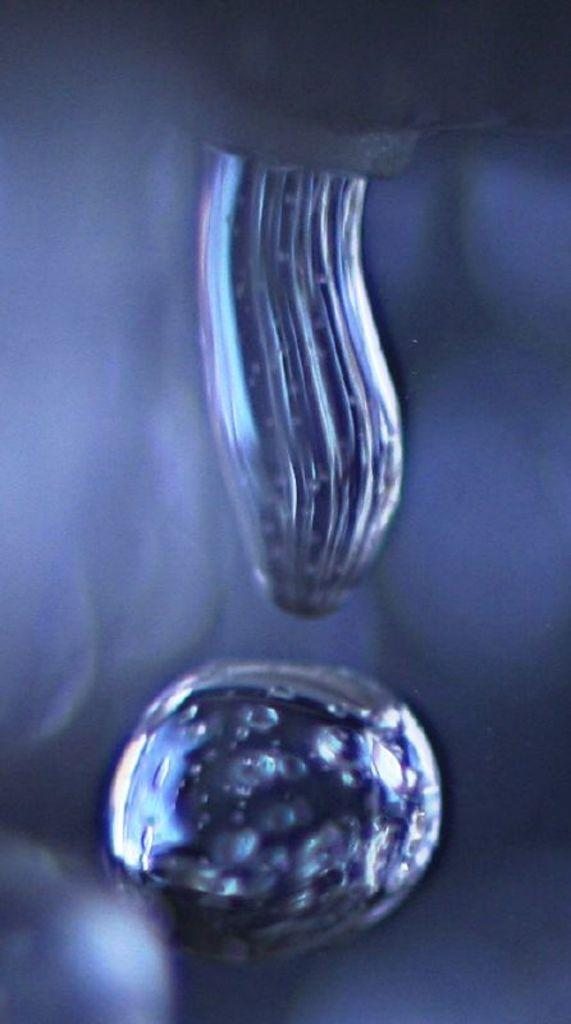What is present in the image? There are water drops in the image. Can you describe the appearance of the water drops? The water drops appear as small, round droplets. What might be the source of the water drops in the image? The source of the water drops could be from rain, condensation, or another form of moisture. How many slaves are depicted in the image? There are no slaves present in the image, as it only features water drops. 